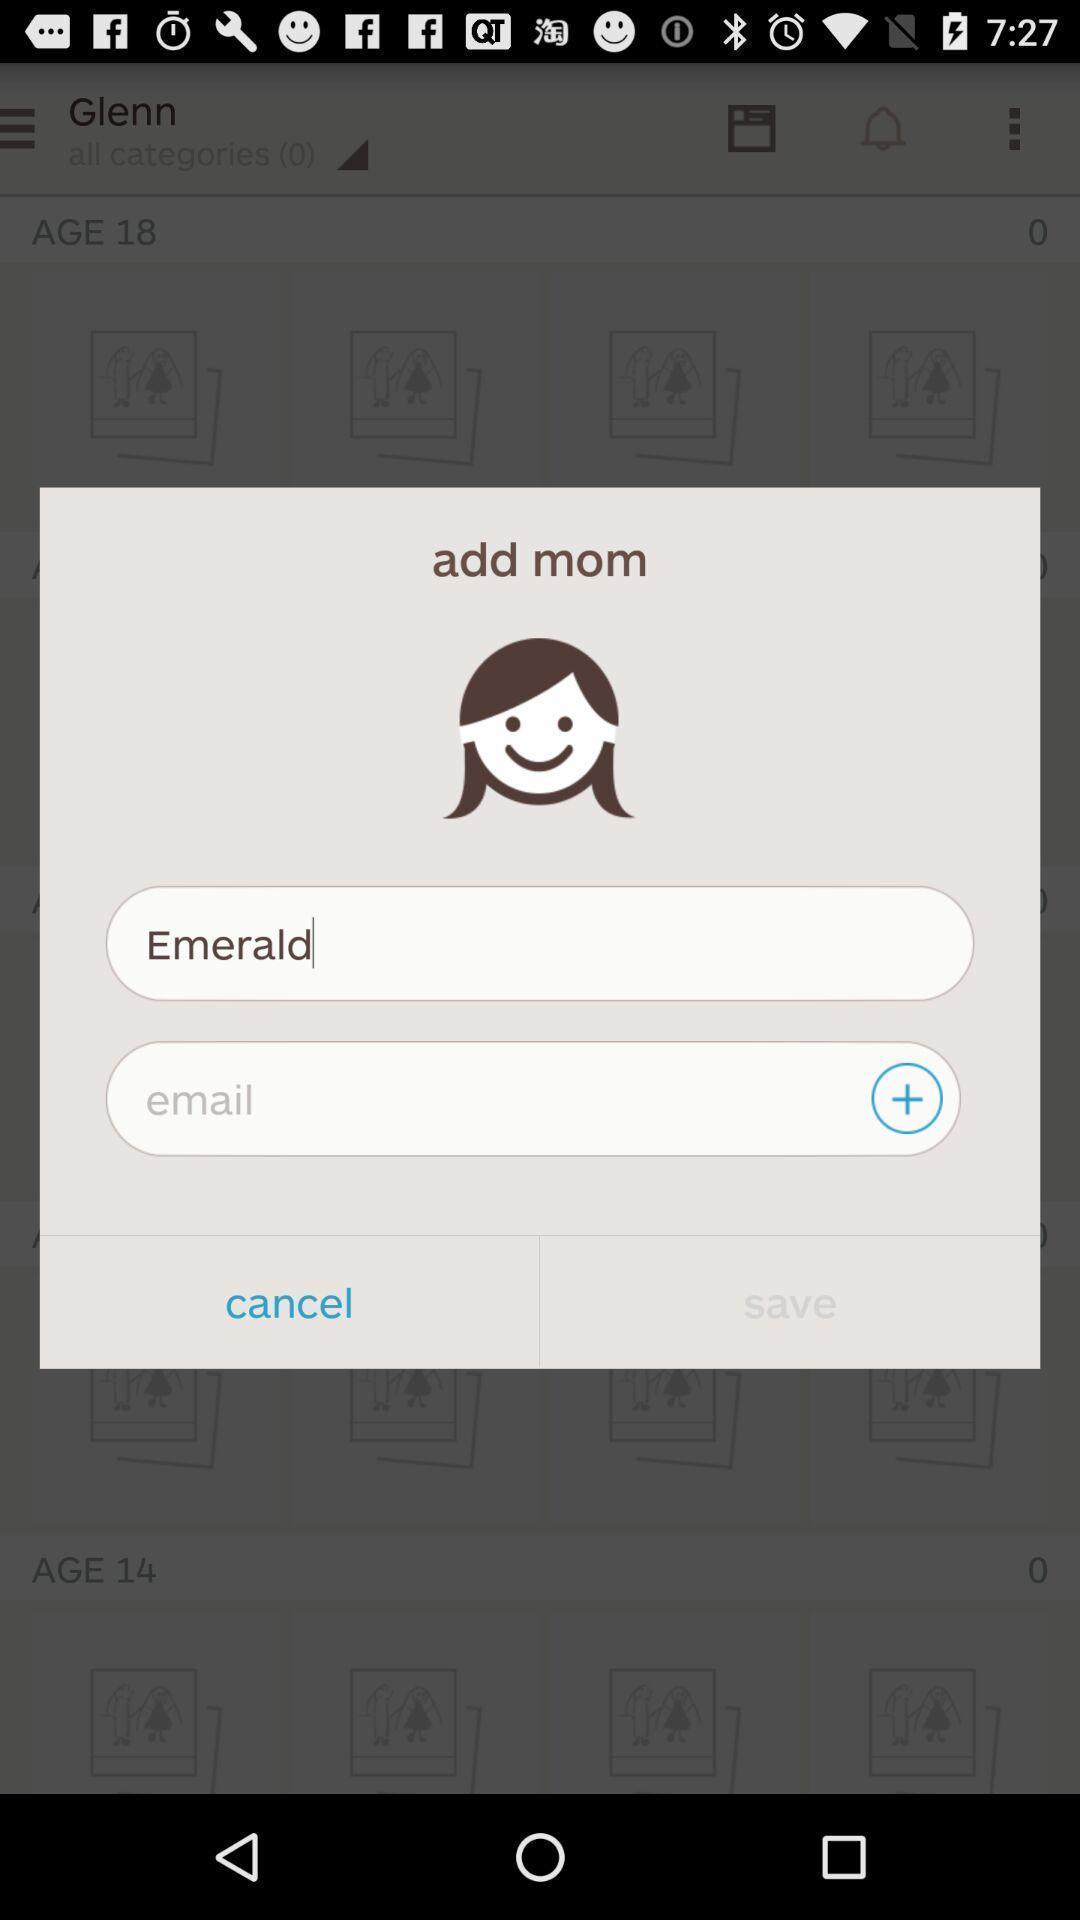What is the overall content of this screenshot? Pop-up displaying to enter details. 